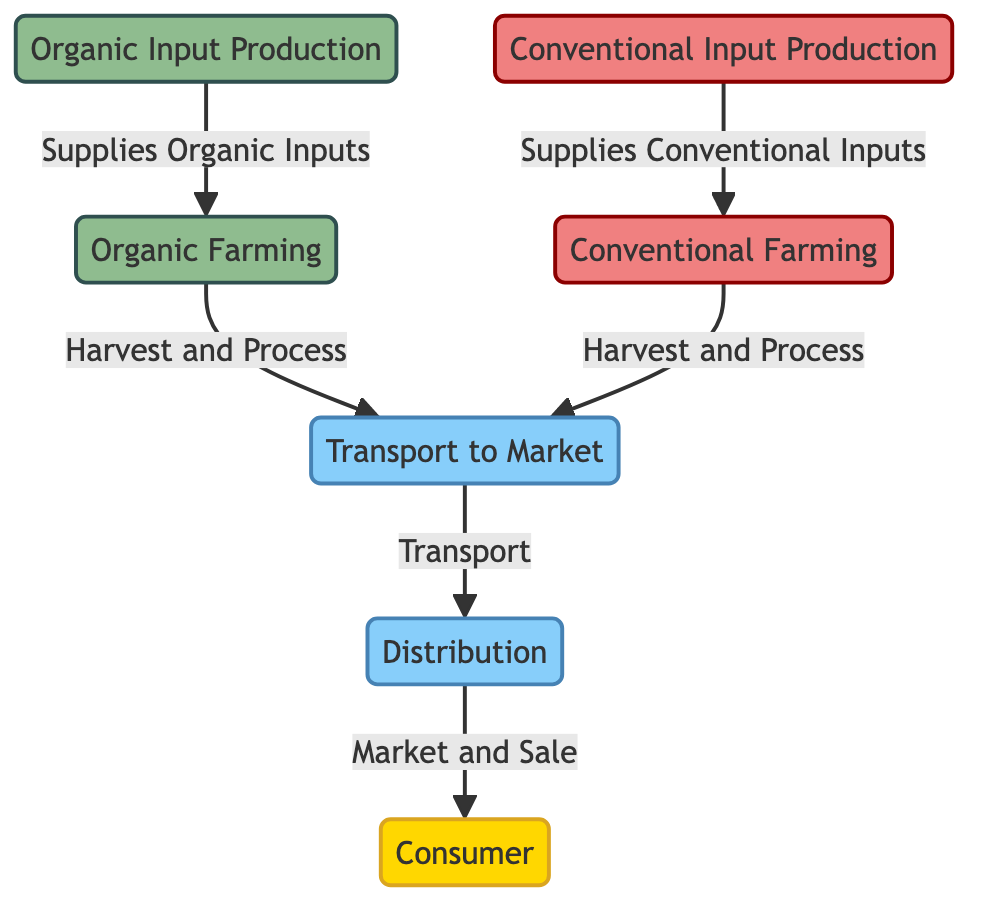What is the first process in organic farming? The diagram indicates that the first process in organic farming is the "Organic Input Production," which supplies organic inputs to the farming stage.
Answer: Organic Input Production How many different types of farming inputs are mentioned? There are two types of farming inputs shown in the diagram: "Organic Input Production" and "Conventional Input Production."
Answer: Two What connects conventional farming to the transport stage? The diagram shows that "Conventional Farming" connects to the transport stage through the "Harvest and Process" relationship.
Answer: Harvest and Process Which node represents the final stage of the food chain? The final stage of the food chain is represented by the "Consumer" node, which is the last point in the process depicted.
Answer: Consumer What type of inputs are supplied to conventional farming? The "Conventional Input Production" node supplies the inputs required for conventional farming practices.
Answer: Conventional Inputs Which type of farming leads to more emission concerns based on the processes shown? Based on the diagram's emphasis on conventional farming methods often associated with higher emissions, it can be inferred that conventional farming leads to more emission concerns compared to organic methods.
Answer: Conventional Farming What is the transport process connecting? The "Transport to Market" node connects both types of farming (organic and conventional) to the "Distribution" node in the diagram, indicating the path of produce after harvest.
Answer: Distribution How many main nodes describe farming types in the diagram? The diagram describes two main farming types: "Organic Farming" and "Conventional Farming."
Answer: Two 